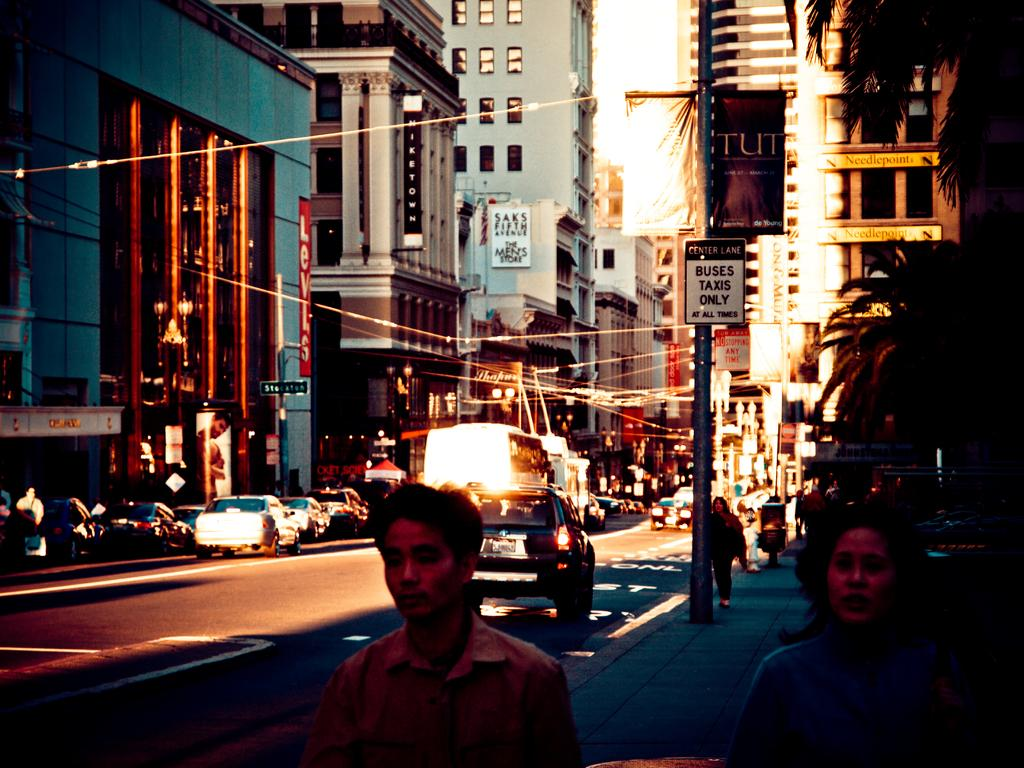Where was the image taken? The image was taken in a street. What can be seen on the road in the image? There are vehicles on the road in the image. What are the people in the image doing? There are people walking on the footpath in the image. What can be seen on either side of the road? There are buildings on either side of the road in the image. What is visible above the buildings? The sky is visible above the buildings in the image. Can you see any feathers floating in the air in the image? No, there are no feathers visible in the image. What type of tooth is being used to cut the building in the image? There is no tooth present in the image, and the buildings are not being cut. 